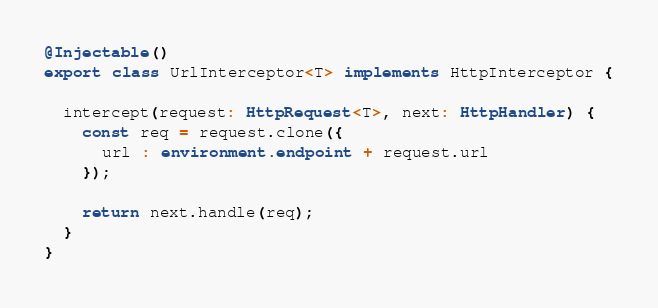Convert code to text. <code><loc_0><loc_0><loc_500><loc_500><_TypeScript_>@Injectable()
export class UrlInterceptor<T> implements HttpInterceptor {

  intercept(request: HttpRequest<T>, next: HttpHandler) {
    const req = request.clone({
      url : environment.endpoint + request.url
    });

    return next.handle(req);
  }
}
</code> 